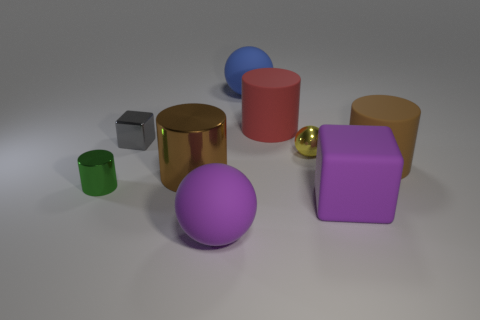Which objects in the image are touching? From the perspective given, it appears that none of the objects are touching each other. They are all placed separately. How can their arrangement give us information about their size? The objects' arrangement, with some objects being closer and others further away, indicates depth. Objects of similar shapes can be compared for size; if one object looks larger than the other and assuming they are at a similar distance from the viewpoint, we can infer that it is indeed larger in size. 